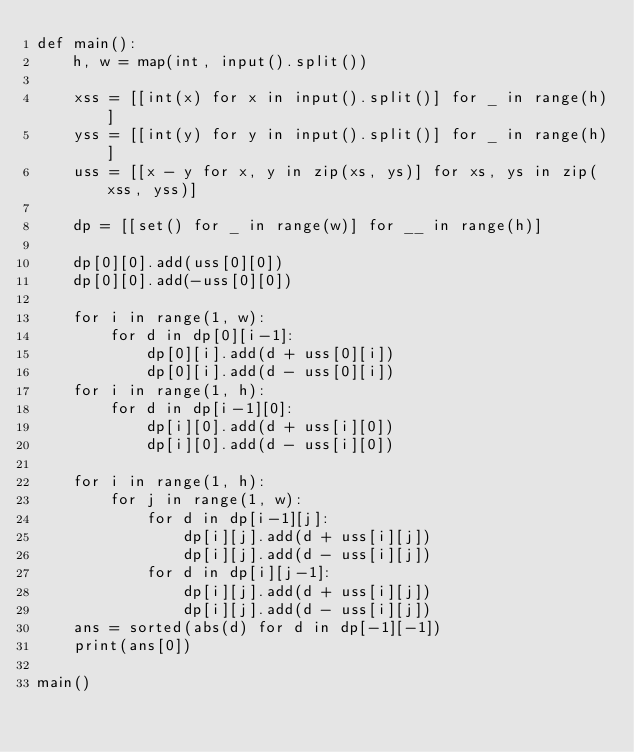<code> <loc_0><loc_0><loc_500><loc_500><_Python_>def main():
    h, w = map(int, input().split())

    xss = [[int(x) for x in input().split()] for _ in range(h)]
    yss = [[int(y) for y in input().split()] for _ in range(h)]
    uss = [[x - y for x, y in zip(xs, ys)] for xs, ys in zip(xss, yss)]

    dp = [[set() for _ in range(w)] for __ in range(h)]

    dp[0][0].add(uss[0][0])
    dp[0][0].add(-uss[0][0])

    for i in range(1, w):
        for d in dp[0][i-1]:
            dp[0][i].add(d + uss[0][i])
            dp[0][i].add(d - uss[0][i])
    for i in range(1, h):
        for d in dp[i-1][0]:
            dp[i][0].add(d + uss[i][0])
            dp[i][0].add(d - uss[i][0])
    
    for i in range(1, h):
        for j in range(1, w):
            for d in dp[i-1][j]:
                dp[i][j].add(d + uss[i][j])
                dp[i][j].add(d - uss[i][j])
            for d in dp[i][j-1]:
                dp[i][j].add(d + uss[i][j])
                dp[i][j].add(d - uss[i][j])
    ans = sorted(abs(d) for d in dp[-1][-1])
    print(ans[0])

main()</code> 